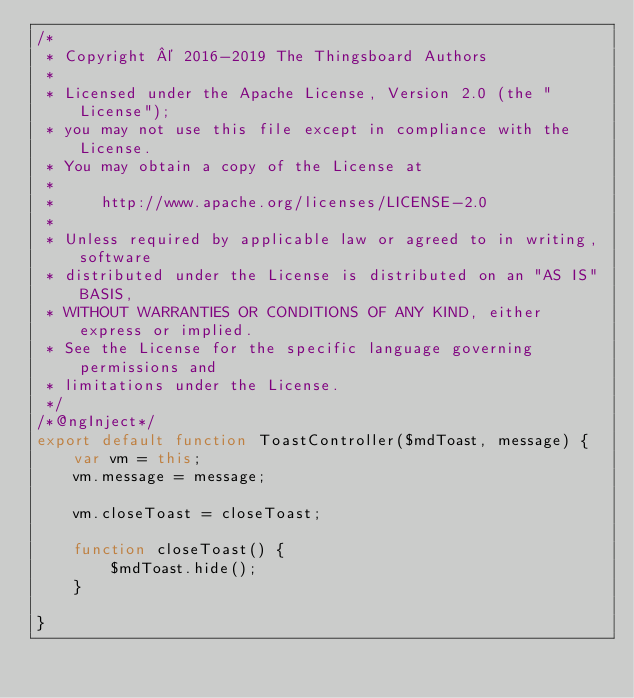Convert code to text. <code><loc_0><loc_0><loc_500><loc_500><_JavaScript_>/*
 * Copyright © 2016-2019 The Thingsboard Authors
 *
 * Licensed under the Apache License, Version 2.0 (the "License");
 * you may not use this file except in compliance with the License.
 * You may obtain a copy of the License at
 *
 *     http://www.apache.org/licenses/LICENSE-2.0
 *
 * Unless required by applicable law or agreed to in writing, software
 * distributed under the License is distributed on an "AS IS" BASIS,
 * WITHOUT WARRANTIES OR CONDITIONS OF ANY KIND, either express or implied.
 * See the License for the specific language governing permissions and
 * limitations under the License.
 */
/*@ngInject*/
export default function ToastController($mdToast, message) {
    var vm = this;
    vm.message = message;

    vm.closeToast = closeToast;

    function closeToast() {
        $mdToast.hide();
    }

}
</code> 